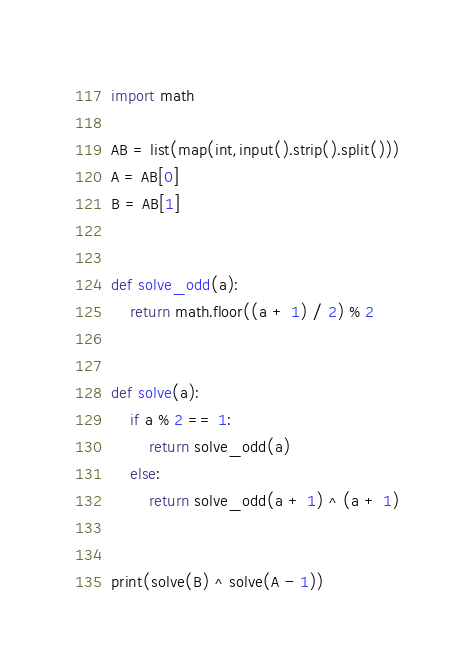Convert code to text. <code><loc_0><loc_0><loc_500><loc_500><_Python_>import math

AB = list(map(int,input().strip().split()))
A = AB[0]
B = AB[1]


def solve_odd(a):
    return math.floor((a + 1) / 2) % 2


def solve(a):
    if a % 2 == 1:
        return solve_odd(a)
    else:
        return solve_odd(a + 1) ^ (a + 1)


print(solve(B) ^ solve(A - 1))</code> 